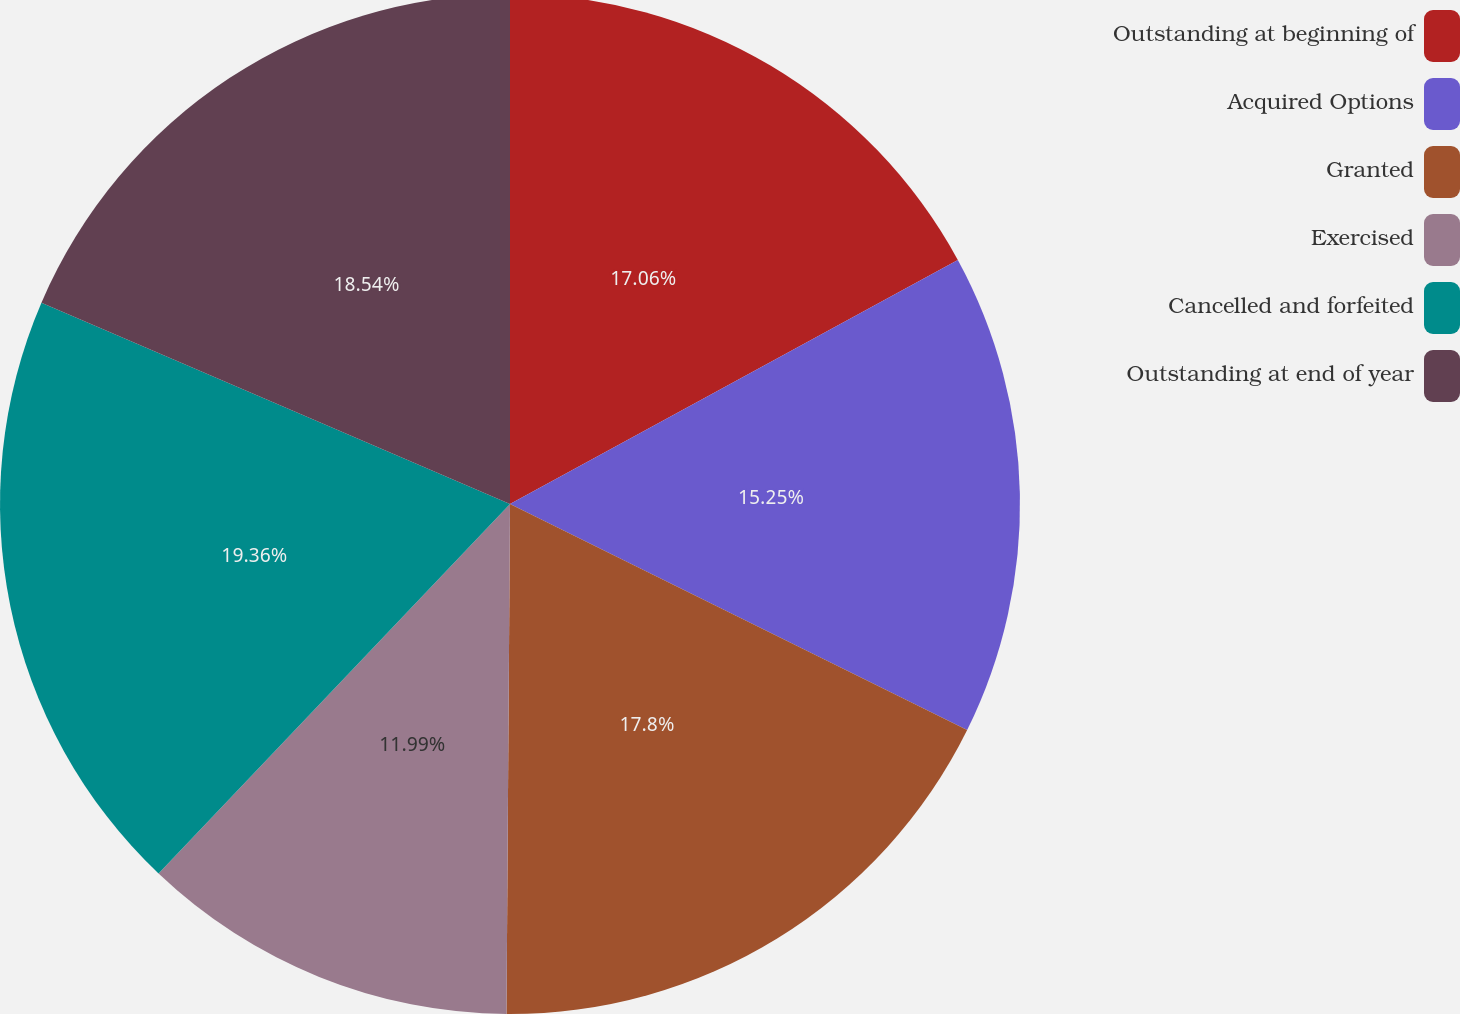Convert chart. <chart><loc_0><loc_0><loc_500><loc_500><pie_chart><fcel>Outstanding at beginning of<fcel>Acquired Options<fcel>Granted<fcel>Exercised<fcel>Cancelled and forfeited<fcel>Outstanding at end of year<nl><fcel>17.06%<fcel>15.25%<fcel>17.8%<fcel>11.99%<fcel>19.36%<fcel>18.54%<nl></chart> 